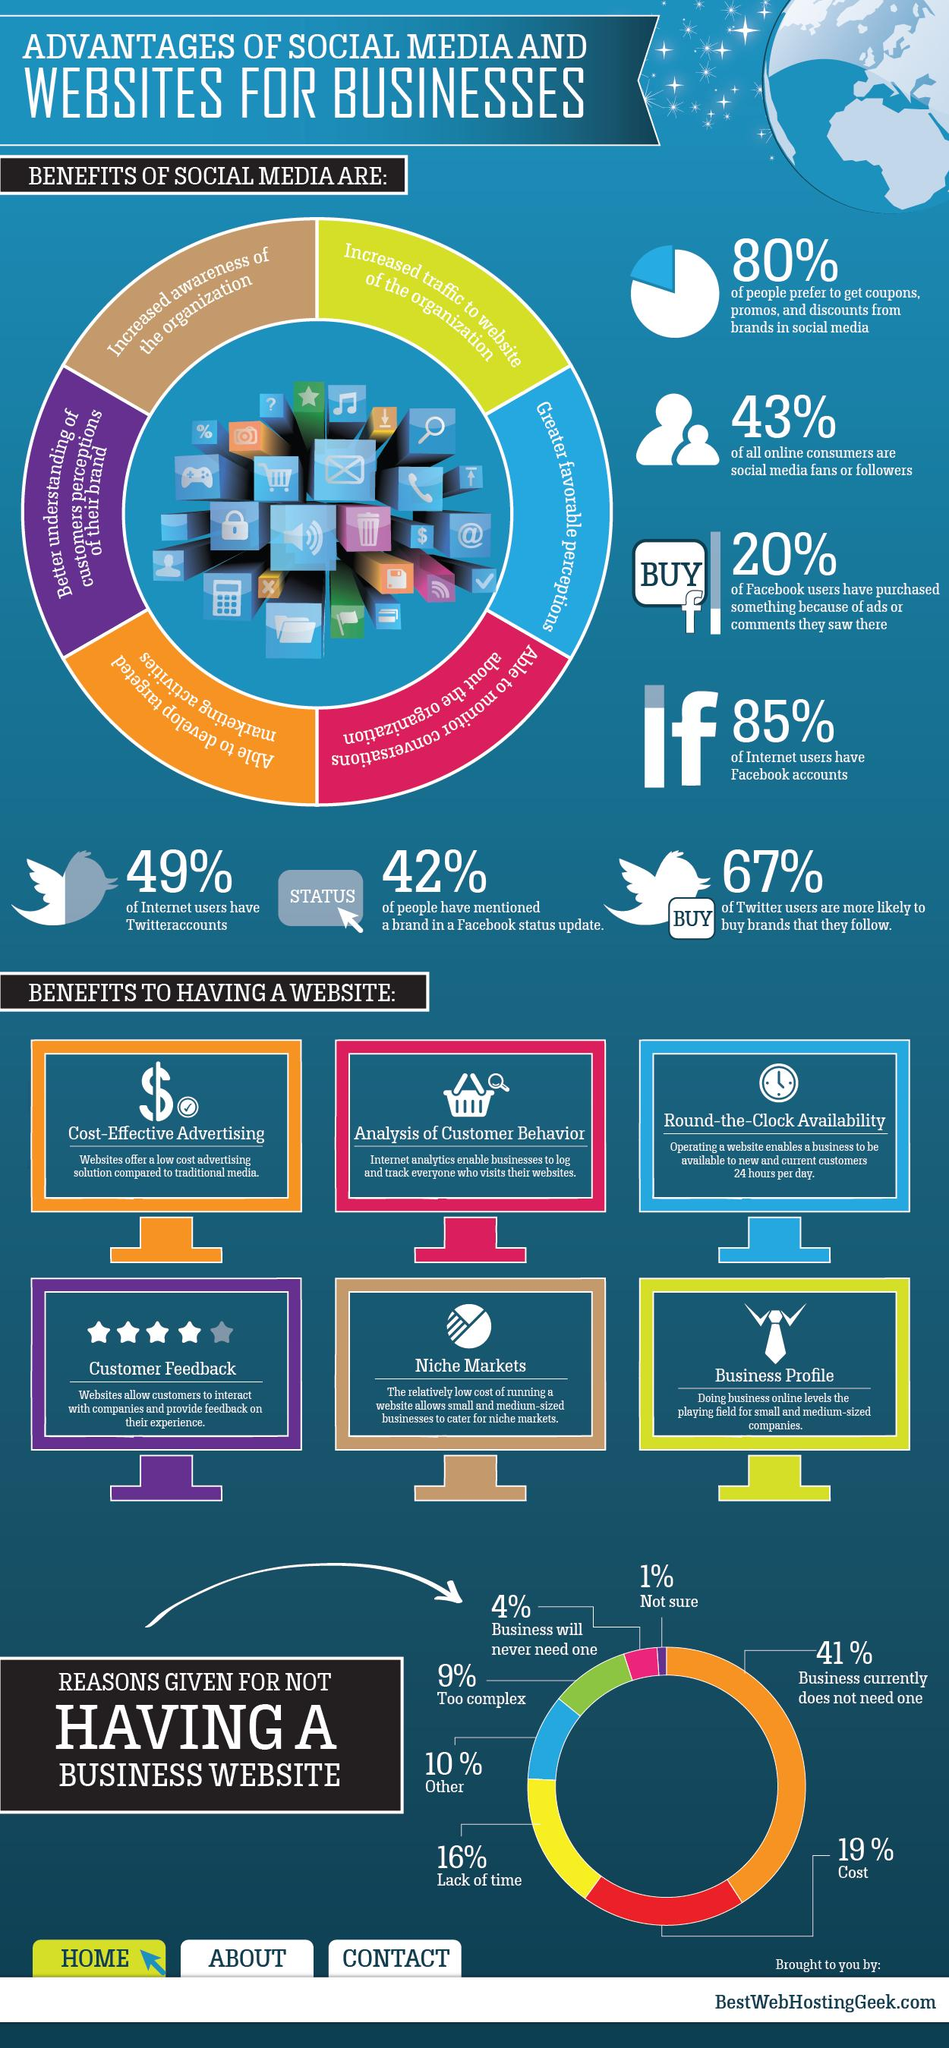Give some essential details in this illustration. The top reason for not having a business website is that the business currently does not need one. A majority of Facebook users, approximately 80%, have not made a purchase due to ads or comments. According to the survey, only 13% of respondents believe that having a website is too complex and that businesses will never need one. Six benefits of having a website have been listed. According to a recent survey, 20% of people do not prefer coupons or promos from brands in social media. 